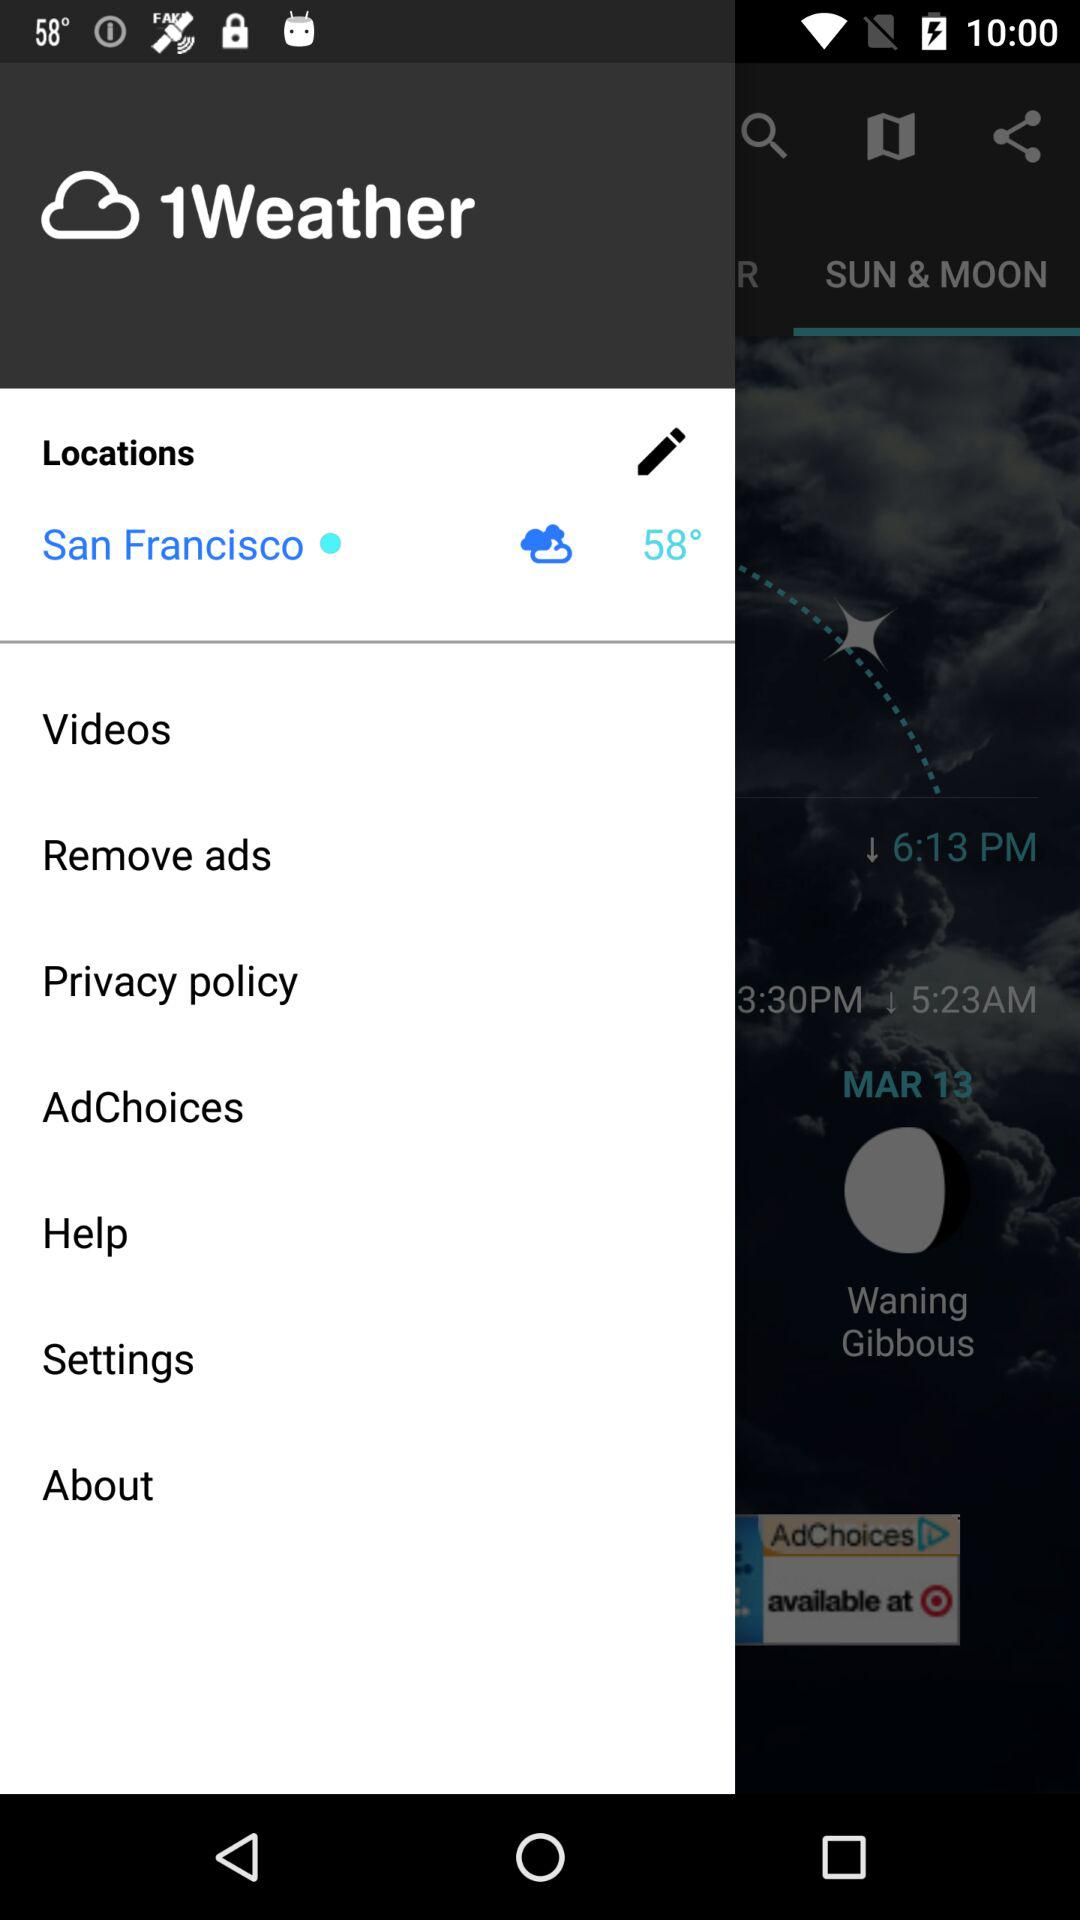What is the temperature? The temperature is 58°. 